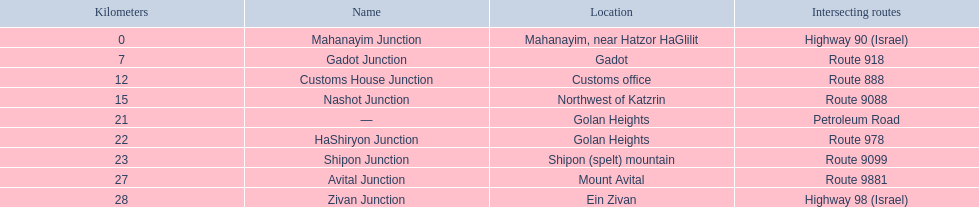What are all the are all the locations on the highway 91 (israel)? Mahanayim, near Hatzor HaGlilit, Gadot, Customs office, Northwest of Katzrin, Golan Heights, Golan Heights, Shipon (spelt) mountain, Mount Avital, Ein Zivan. What are the distance values in kilometers for ein zivan, gadot junction and shipon junction? 7, 23, 28. Which is the least distance away? 7. What is the name? Gadot Junction. 